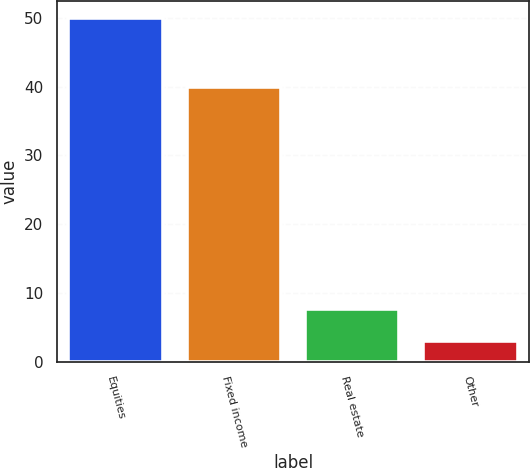<chart> <loc_0><loc_0><loc_500><loc_500><bar_chart><fcel>Equities<fcel>Fixed income<fcel>Real estate<fcel>Other<nl><fcel>50<fcel>40<fcel>7.7<fcel>3<nl></chart> 